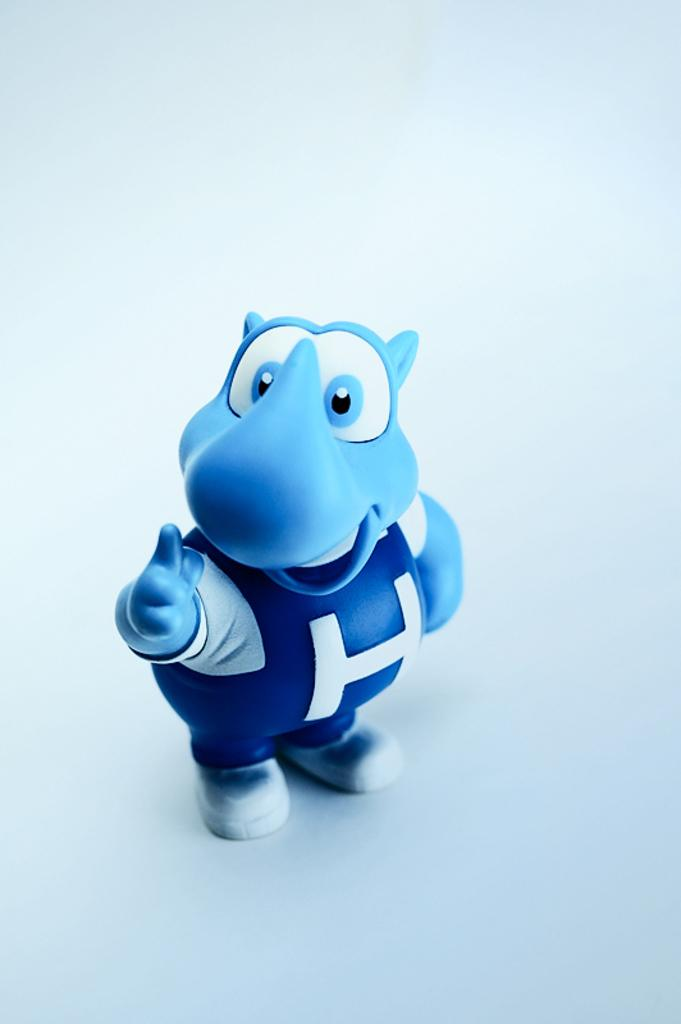What type of image is being described? The image is animated. What color is the background of the image? The background of the image is white. What can be found in the middle of the image? There is a toy in the middle of the image. How many frogs are present in the image? There are no frogs present in the image; it features an animated toy in the middle of a white background. What territory is being claimed by the pail in the image? There is no pail present in the image, so no territory is being claimed. 